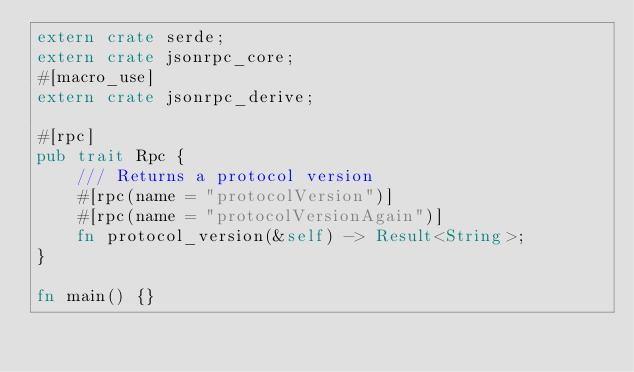<code> <loc_0><loc_0><loc_500><loc_500><_Rust_>extern crate serde;
extern crate jsonrpc_core;
#[macro_use]
extern crate jsonrpc_derive;

#[rpc]
pub trait Rpc {
	/// Returns a protocol version
	#[rpc(name = "protocolVersion")]
	#[rpc(name = "protocolVersionAgain")]
	fn protocol_version(&self) -> Result<String>;
}

fn main() {}
</code> 